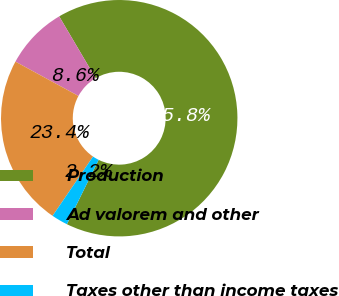<chart> <loc_0><loc_0><loc_500><loc_500><pie_chart><fcel>Production<fcel>Ad valorem and other<fcel>Total<fcel>Taxes other than income taxes<nl><fcel>65.77%<fcel>8.58%<fcel>23.41%<fcel>2.23%<nl></chart> 